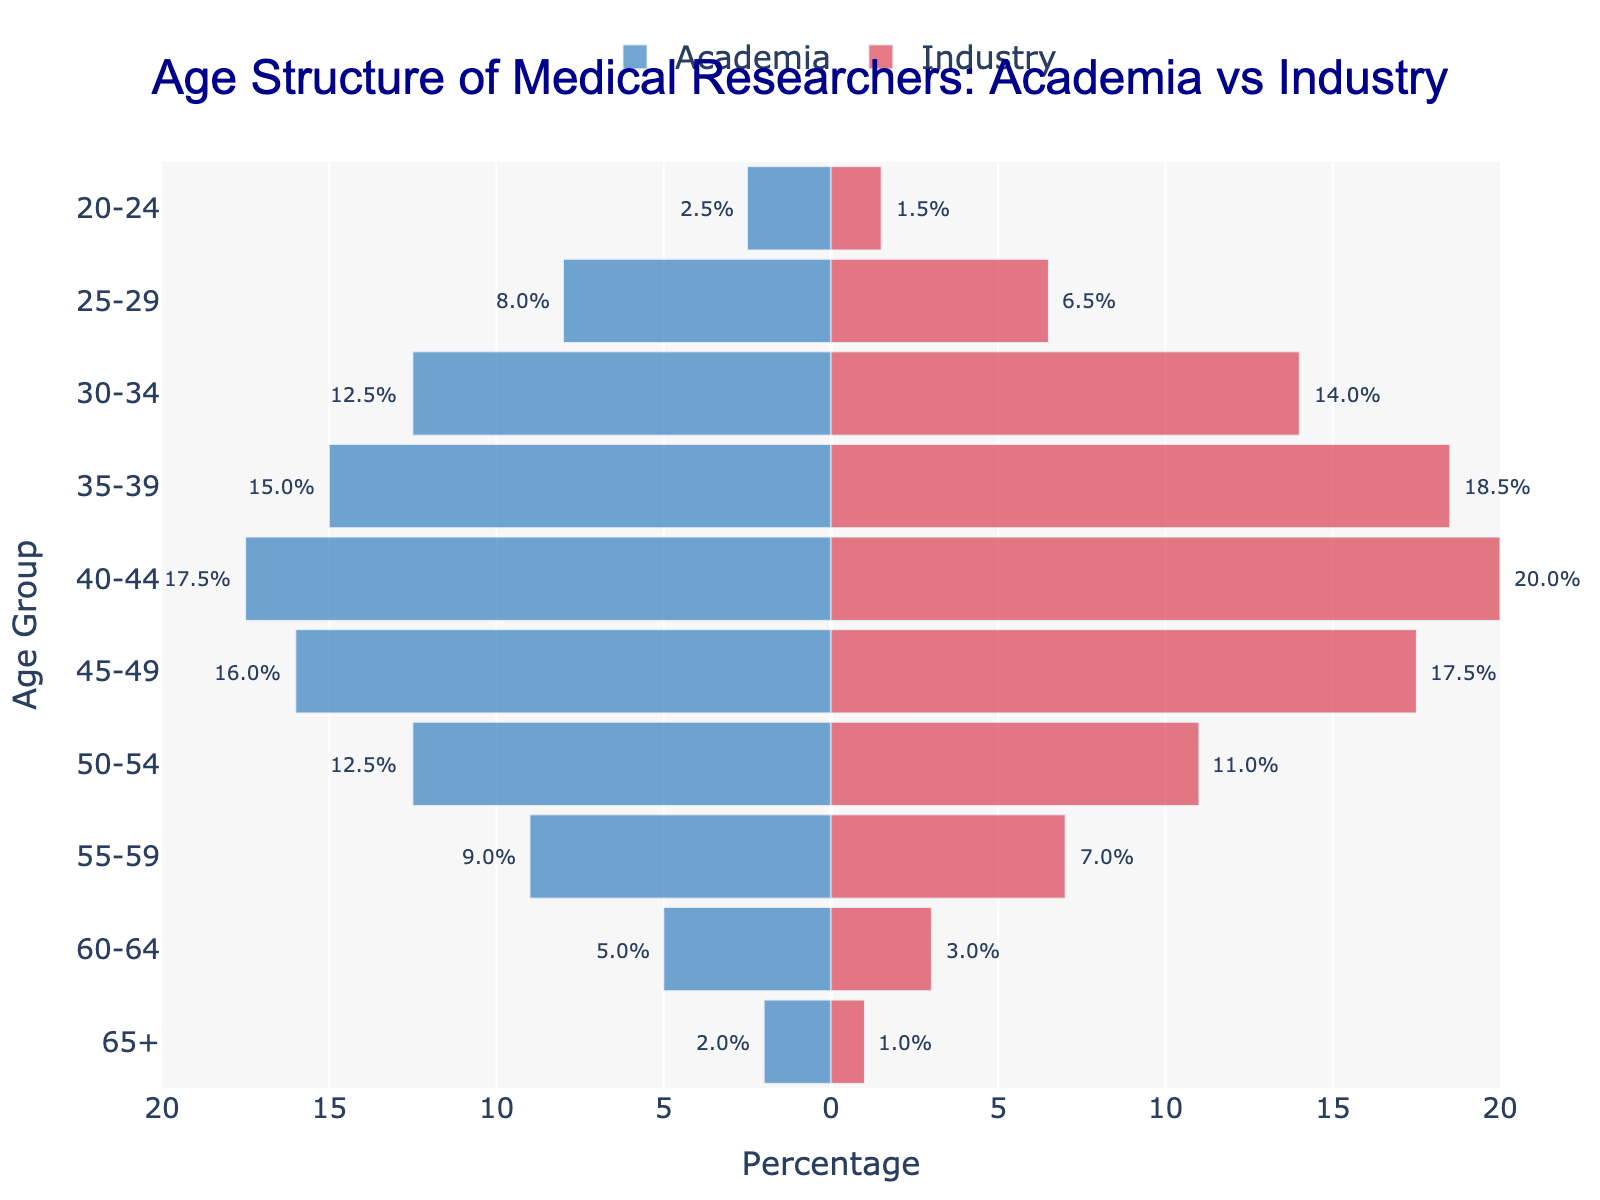What is the title of the figure? The title is displayed at the top of the figure and reads "Age Structure of Medical Researchers: Academia vs Industry".
Answer: Age Structure of Medical Researchers: Academia vs Industry What age group has the highest percentage in Industry? By examining the Industry side of the pyramid, the age group with the highest percentage is 40-44 with 20.0%.
Answer: 40-44 Which age group has a higher percentage in Academia than in Industry? By comparing the two bars side-by-side for each age group, we see that 20-24, 25-29, 50-54, 55-59, 60-64, and 65+ have higher percentages in Academia than in Industry.
Answer: 20-24, 25-29, 50-54, 55-59, 60-64, 65+ How does the percentage of researchers aged 50-54 in Academia compare to those in Industry? For the age group 50-54, the percentage in Academia is 12.5% and in Industry is 11.0%. Academia has a higher percentage by 1.5%.
Answer: Academia is higher by 1.5% What is the total percentage of researchers aged 35-39 for both Academia and Industry combined? The percentage for the age group 35-39 is 15.0% in Academia and 18.5% in Industry. Adding these together, we get 15.0% + 18.5% = 33.5%.
Answer: 33.5% In which age group is the difference in percentage between Academia and Industry the smallest? By subtracting the percentages for each age group, we find that the smallest difference is in the age group 50-54, with a difference of 1.5% (12.5% - 11.0%).
Answer: 50-54 Which side of the plot (Academia or Industry) has a wider range of age groups with higher percentages? By examining the range of percentages for both sides, we observe that Industry has a higher range of percentages from 1.0% to 20.0%, whereas Academia ranges from 2.0% to 17.5%. Industry has the wider range.
Answer: Industry For which age group is the percentage closest to 10% on both sides? Looking at the age groups on both sides, the closest age groups to 10% are 50-54 in Industry with 11.0% and 55-59 in Academia with 9.0%.
Answer: 50-54 in Industry and 55-59 in Academia 